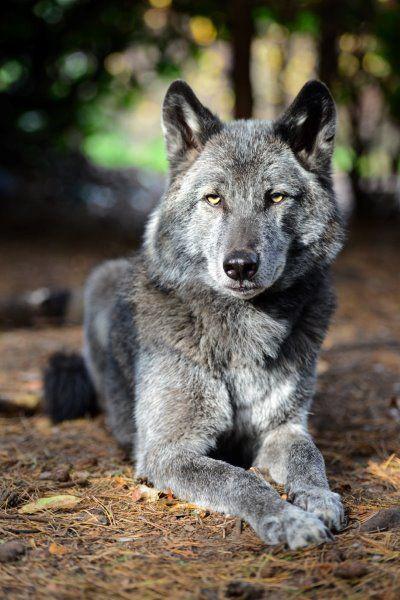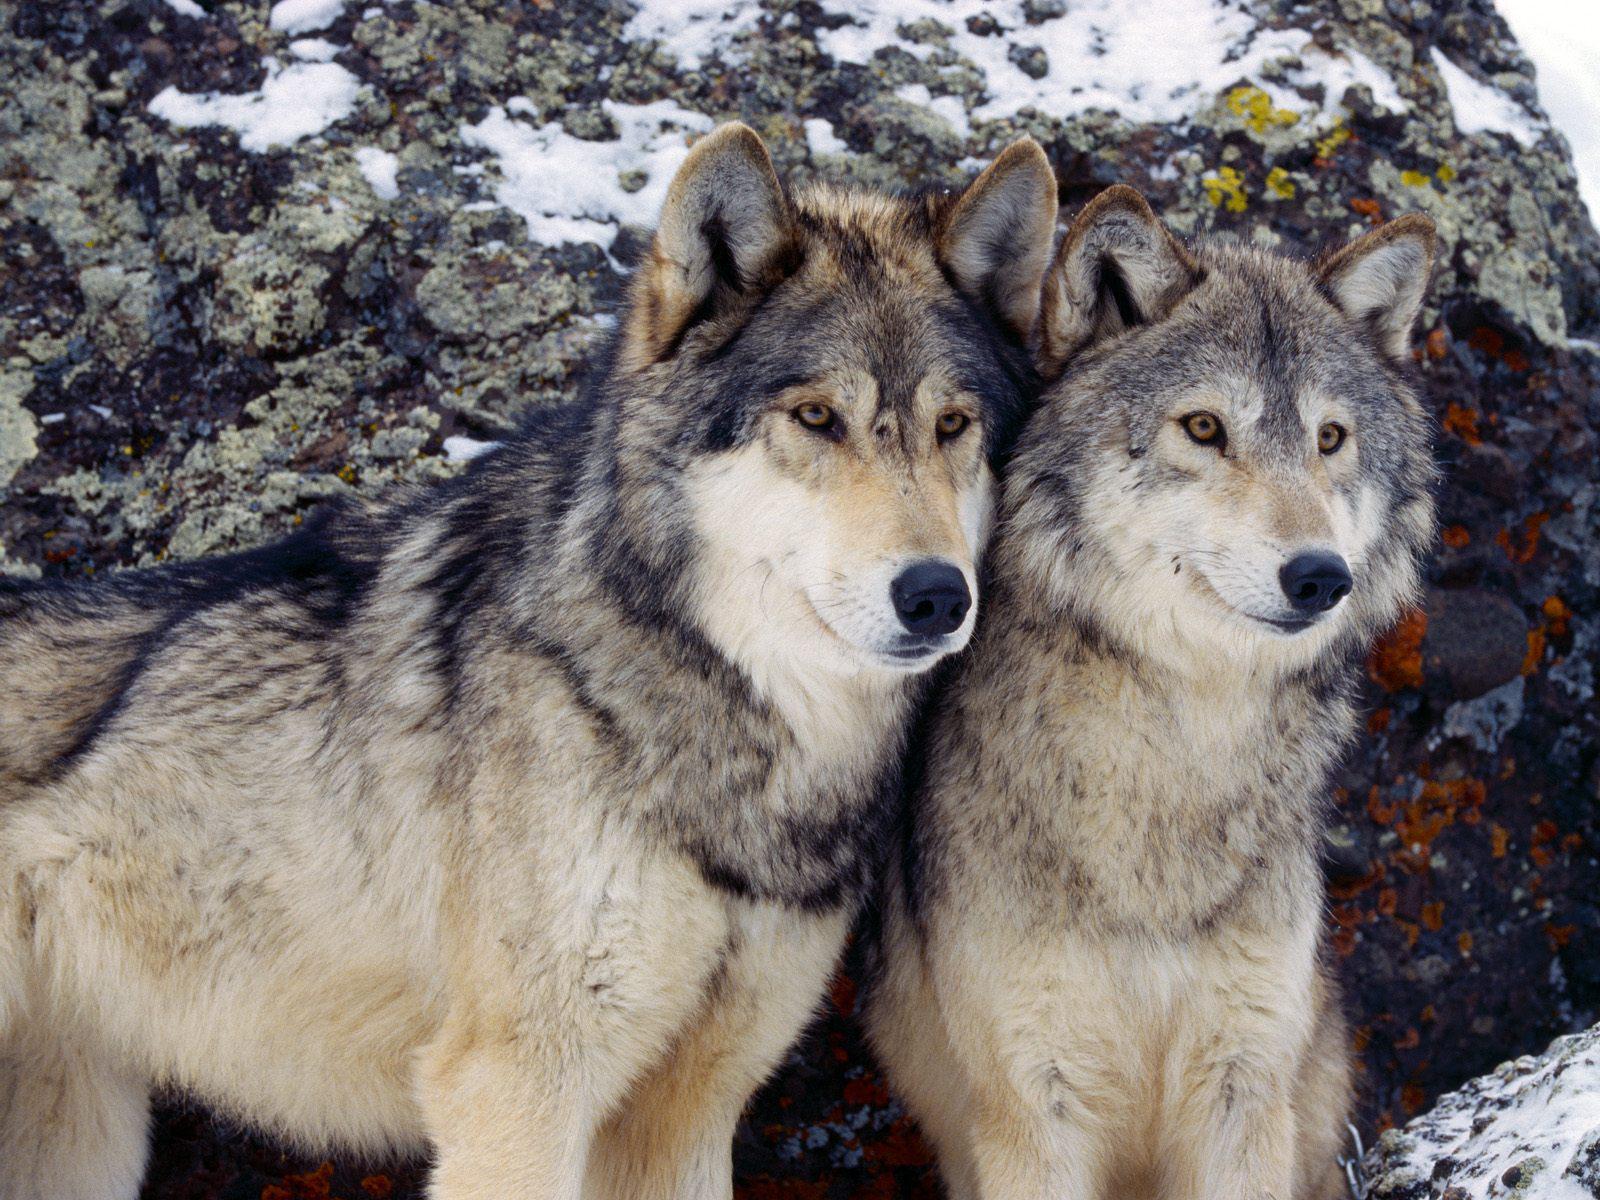The first image is the image on the left, the second image is the image on the right. Considering the images on both sides, is "One image contains more than one wolf, and one image contains a single wolf, who is standing on all fours." valid? Answer yes or no. No. 